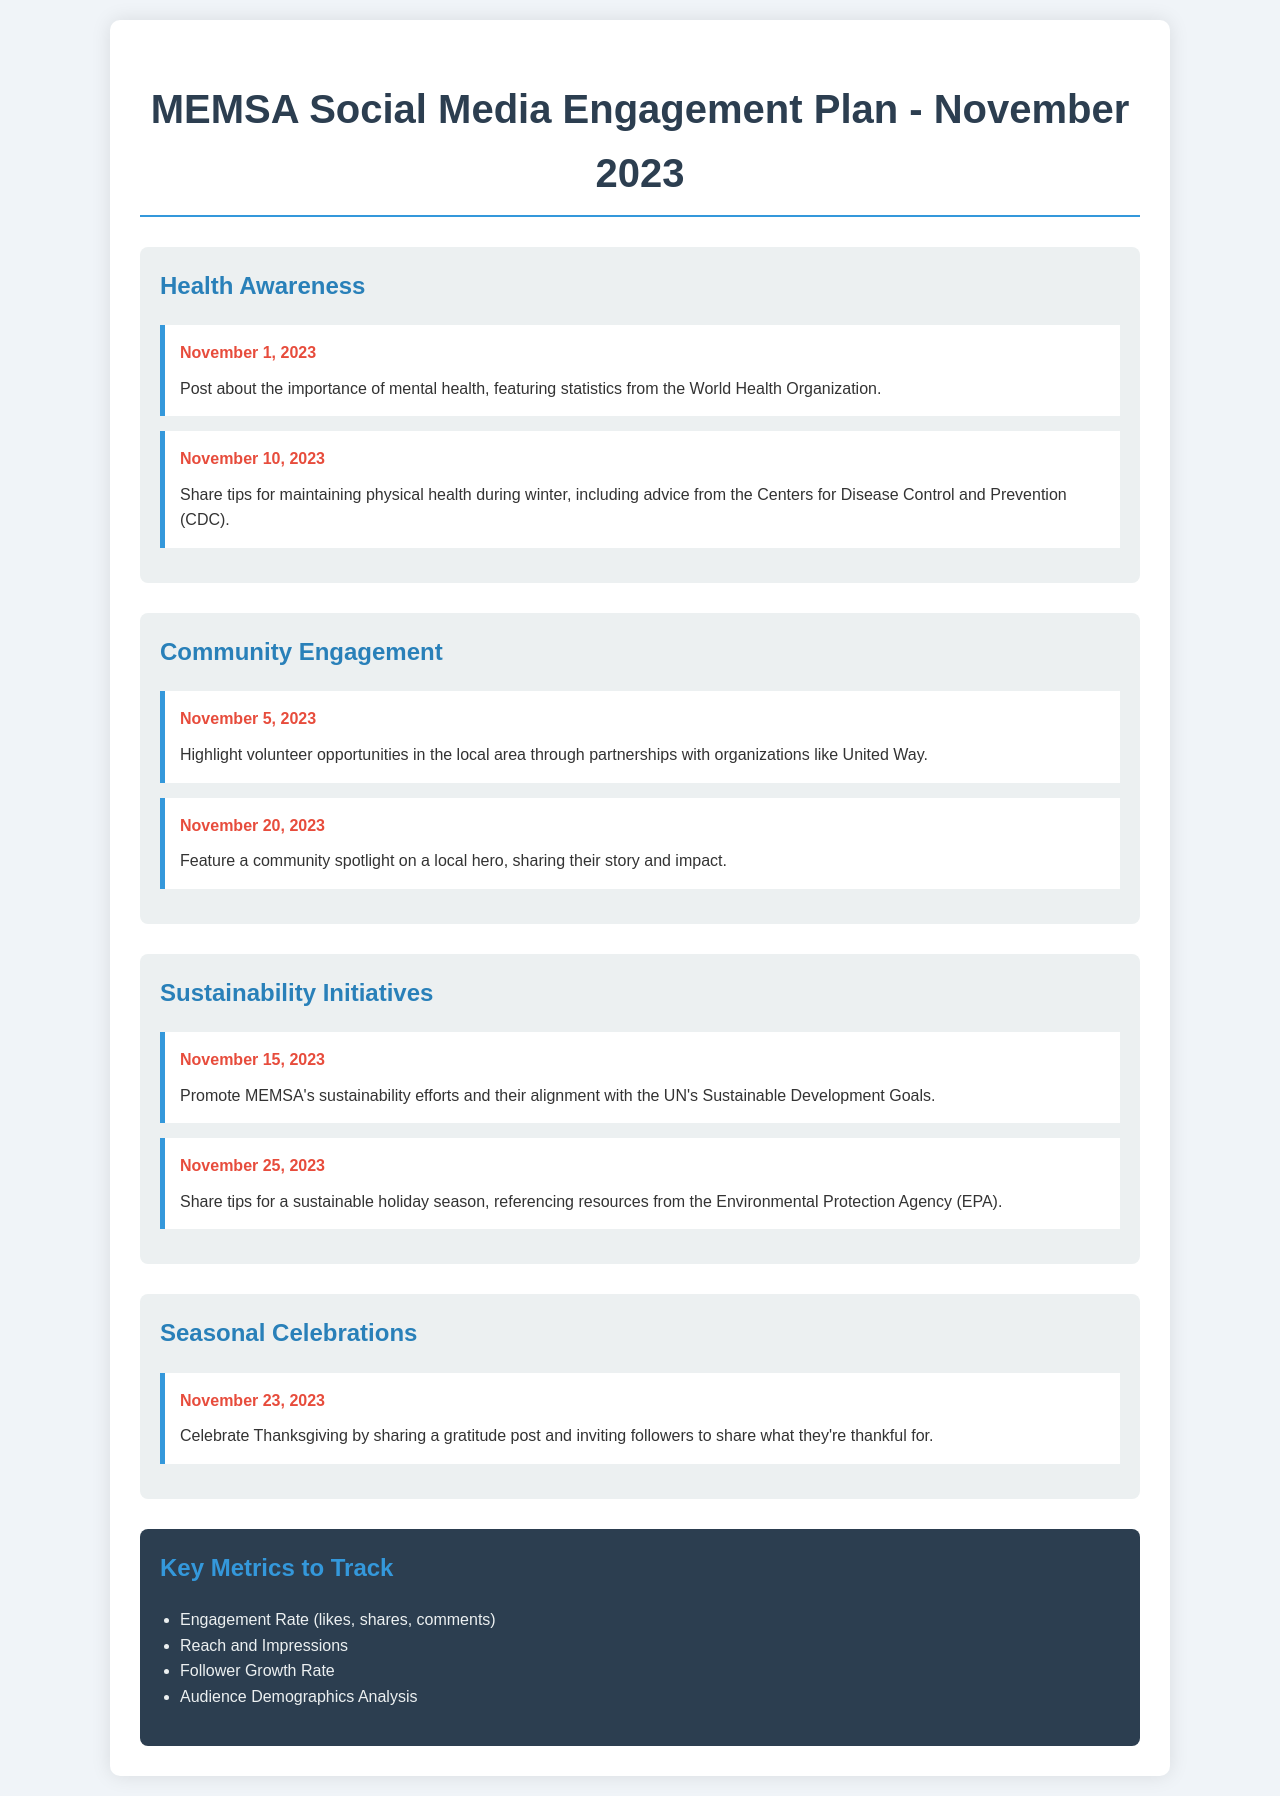What is the title of the document? The title of the document is prominently displayed at the top and identifies the focus and date of the engagement plan.
Answer: MEMSA Social Media Engagement Plan - November 2023 How many posts are scheduled for Health Awareness in November? The Health Awareness theme includes two scheduled posts for the month of November.
Answer: 2 When is the post about volunteer opportunities scheduled? The specific date for highlighting volunteer opportunities is listed under the Community Engagement theme.
Answer: November 5, 2023 What is one key metric to track according to the document? The document outlines several metrics, and one key metric is explicitly mentioned in the list of metrics to track.
Answer: Engagement Rate (likes, shares, comments) How many themes are covered in the engagement plan? By counting the sections in the document, the total number of distinct themes can be determined.
Answer: 4 What is the content of the post scheduled for November 23, 2023? The content associated with this date is clearly stated under the Seasonal Celebrations theme.
Answer: Celebrate Thanksgiving by sharing a gratitude post and inviting followers to share what they're thankful for Which organization is referenced in the post about physical health? The specific organization providing the advice about maintaining physical health is mentioned in connection with the associated post.
Answer: Centers for Disease Control and Prevention (CDC) On what date is the sustainability tips post scheduled? The date of posting sustainability tips is listed under the Sustainability Initiatives theme.
Answer: November 25, 2023 What color is used for the header in the metrics section? The metrics section has a specific color scheme that can be described based on its presentation in the document.
Answer: #2c3e50 